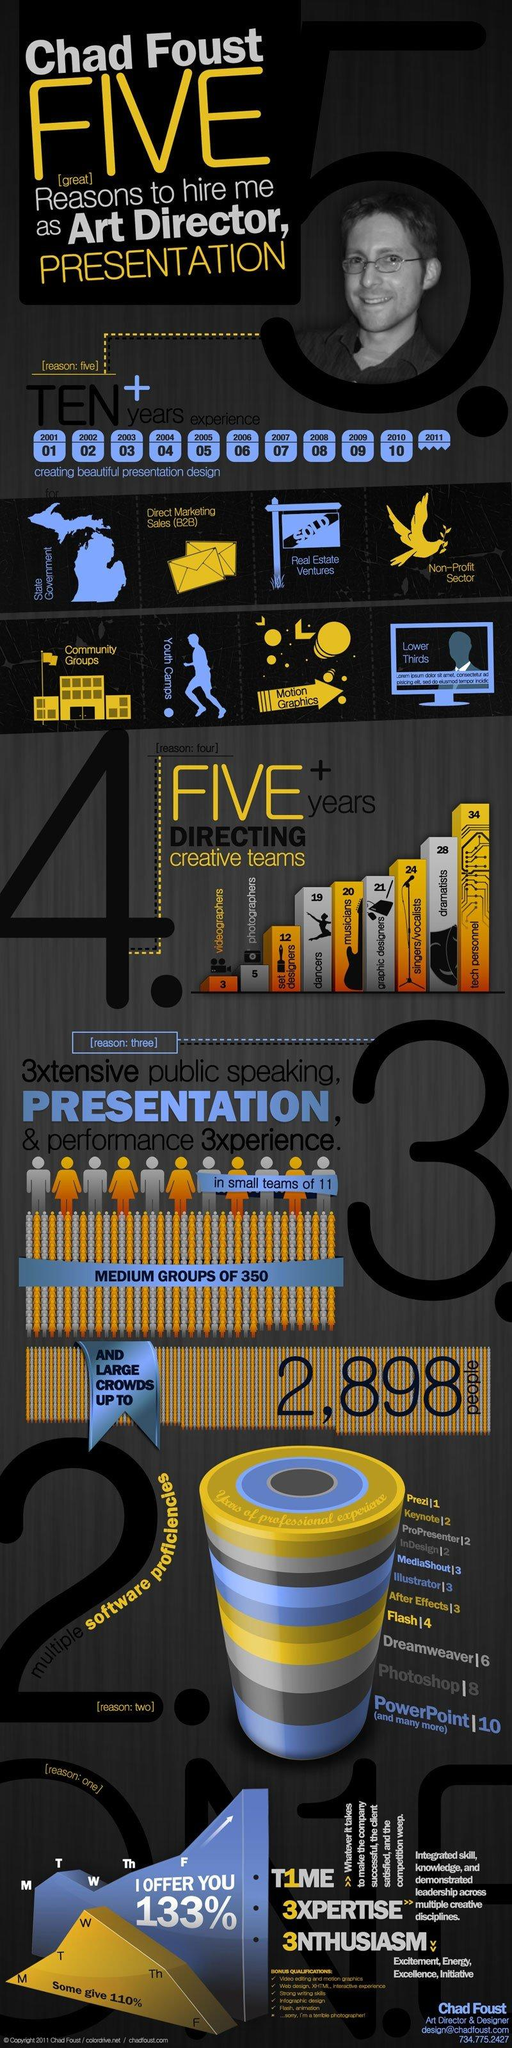Outline some significant characteristics in this image. Chad Foust has directed a variety of creative teams in different fields, but among the dramatists, he has directed the second biggest category. 